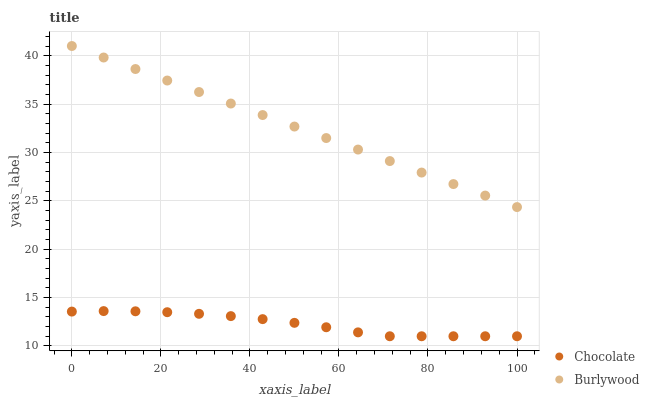Does Chocolate have the minimum area under the curve?
Answer yes or no. Yes. Does Burlywood have the maximum area under the curve?
Answer yes or no. Yes. Does Chocolate have the maximum area under the curve?
Answer yes or no. No. Is Burlywood the smoothest?
Answer yes or no. Yes. Is Chocolate the roughest?
Answer yes or no. Yes. Is Chocolate the smoothest?
Answer yes or no. No. Does Chocolate have the lowest value?
Answer yes or no. Yes. Does Burlywood have the highest value?
Answer yes or no. Yes. Does Chocolate have the highest value?
Answer yes or no. No. Is Chocolate less than Burlywood?
Answer yes or no. Yes. Is Burlywood greater than Chocolate?
Answer yes or no. Yes. Does Chocolate intersect Burlywood?
Answer yes or no. No. 